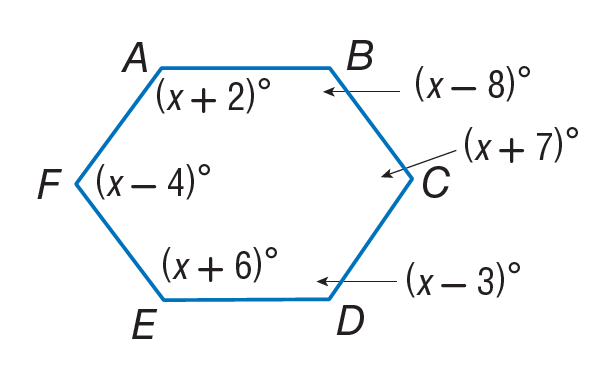Answer the mathemtical geometry problem and directly provide the correct option letter.
Question: Find m \angle B.
Choices: A: 112 B: 116 C: 122 D: 127 A 